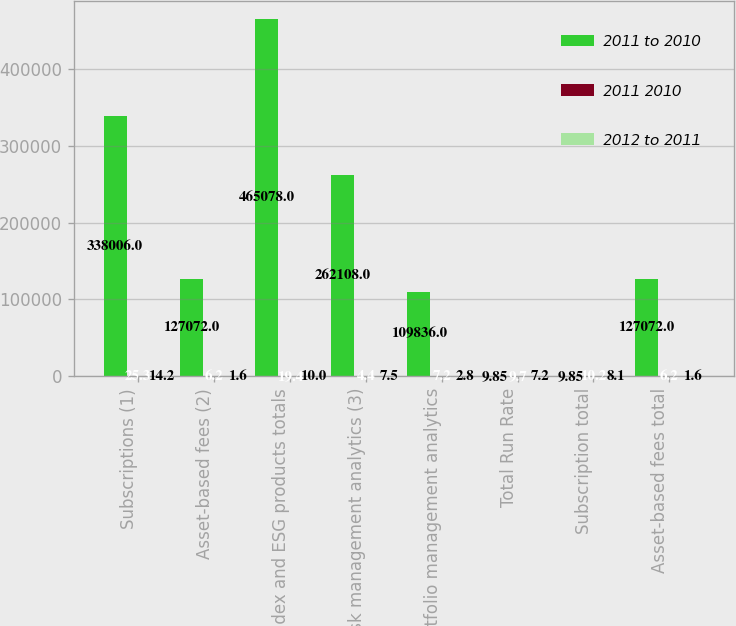Convert chart. <chart><loc_0><loc_0><loc_500><loc_500><stacked_bar_chart><ecel><fcel>Subscriptions (1)<fcel>Asset-based fees (2)<fcel>Index and ESG products totals<fcel>Risk management analytics (3)<fcel>Portfolio management analytics<fcel>Total Run Rate<fcel>Subscription total<fcel>Asset-based fees total<nl><fcel>2011 to 2010<fcel>338006<fcel>127072<fcel>465078<fcel>262108<fcel>109836<fcel>9.85<fcel>9.85<fcel>127072<nl><fcel>2011 2010<fcel>25.3<fcel>6.2<fcel>19.4<fcel>4.4<fcel>7.2<fcel>9.7<fcel>10.2<fcel>6.2<nl><fcel>2012 to 2011<fcel>14.2<fcel>1.6<fcel>10<fcel>7.5<fcel>2.8<fcel>7.2<fcel>8.1<fcel>1.6<nl></chart> 